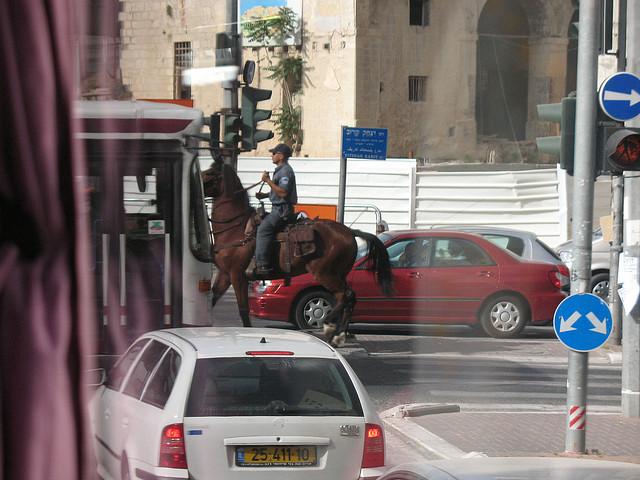What is the license plate number on the white car?
Give a very brief answer. 25-411-10. Is the red car a Mercedes?
Give a very brief answer. No. What color is the horse?
Keep it brief. Brown. 